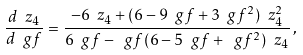<formula> <loc_0><loc_0><loc_500><loc_500>\frac { d \ z _ { 4 } } { d \ g f } = \frac { - 6 \ z _ { 4 } + ( 6 - 9 \ g f + 3 \ g f ^ { 2 } ) \ z _ { 4 } ^ { 2 } } { 6 \ g f - \ g f ( 6 - 5 \ g f + \ g f ^ { 2 } ) \ z _ { 4 } } \, ,</formula> 